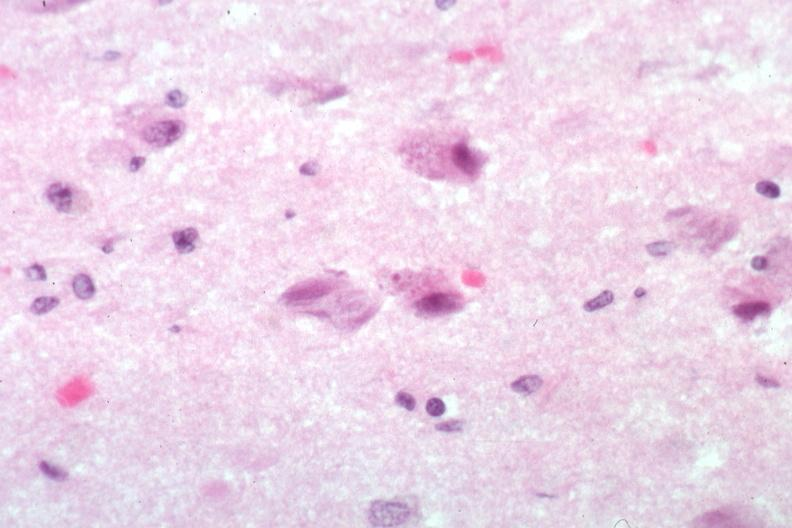s neurofibrillary change present?
Answer the question using a single word or phrase. Yes 